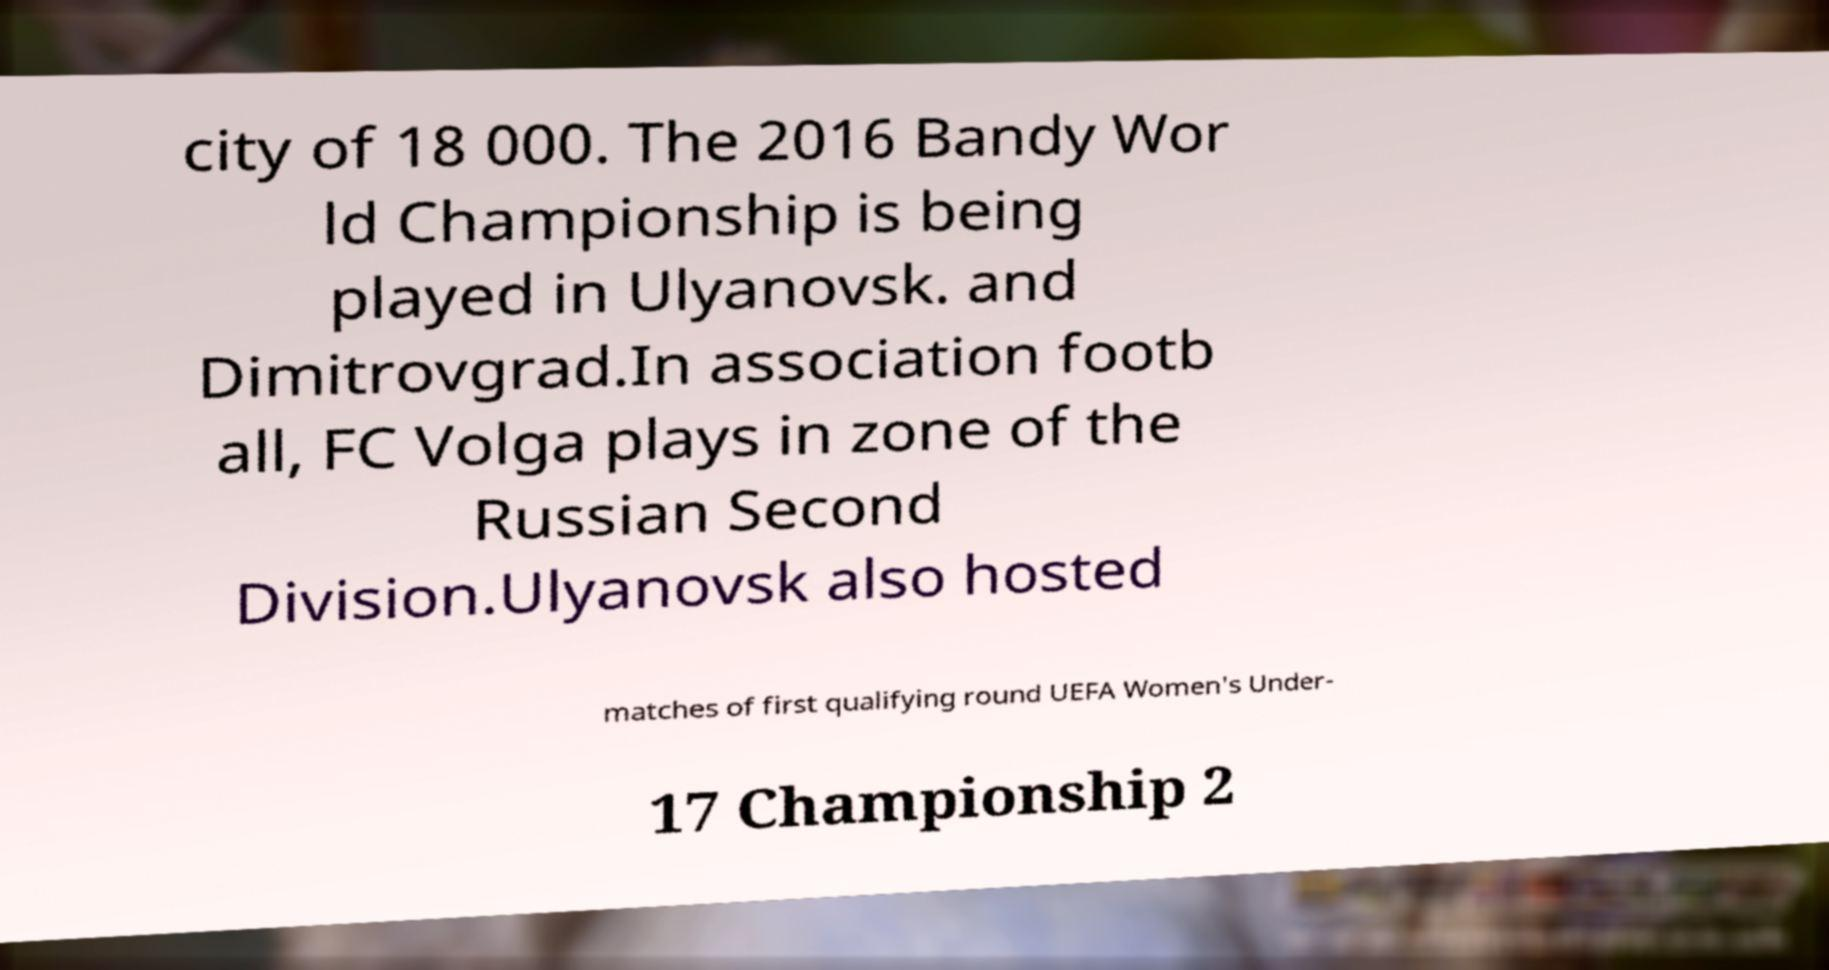Could you assist in decoding the text presented in this image and type it out clearly? city of 18 000. The 2016 Bandy Wor ld Championship is being played in Ulyanovsk. and Dimitrovgrad.In association footb all, FC Volga plays in zone of the Russian Second Division.Ulyanovsk also hosted matches of first qualifying round UEFA Women's Under- 17 Championship 2 